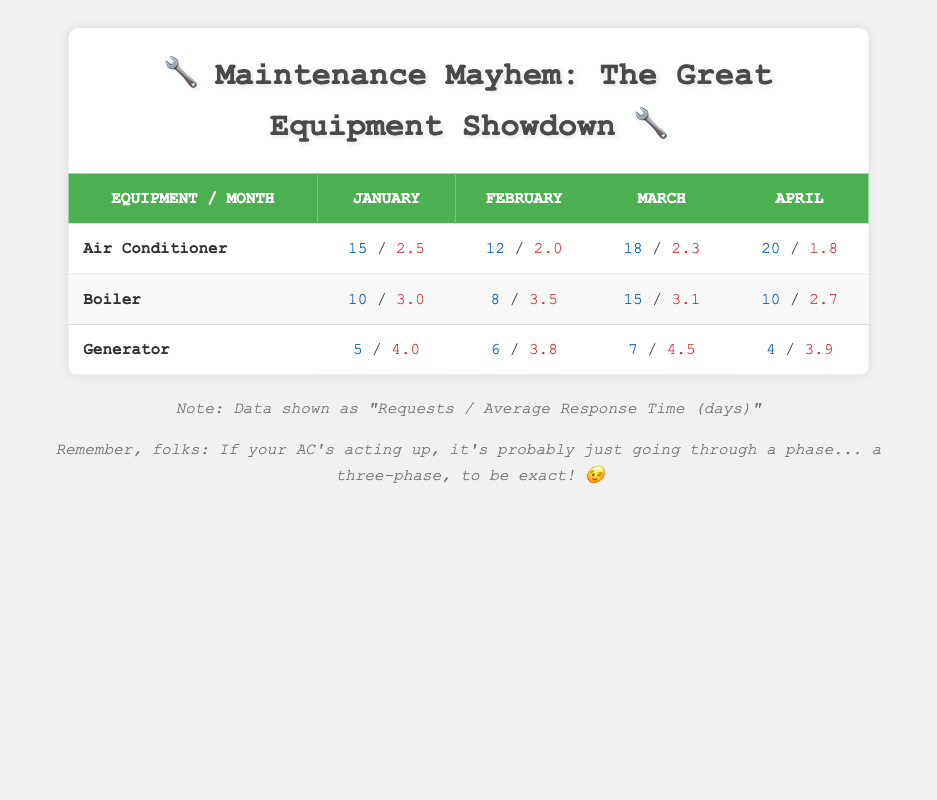What is the average response time for maintenance requests related to the Air Conditioner in April? In April, the average response time for the Air Conditioner is listed in the table as 1.8 days.
Answer: 1.8 days How many maintenance requests were made for the Generator in January? The table shows that there were 5 requests made for the Generator in January.
Answer: 5 requests Which equipment type had the highest number of maintenance requests in March? In March, the Air Conditioner had the highest requests with 18, compared to 15 for the Boiler and 7 for the Generator.
Answer: Air Conditioner What is the total number of maintenance requests for Boiler across all four months? The requests for Boiler in January (10), February (8), March (15), and April (10) total to 10 + 8 + 15 + 10 = 43 requests.
Answer: 43 requests Was the average response time for the Generator higher in January than in February? In January, the average response time for the Generator was 4.0 days, while in February, it was 3.8 days, thus it was higher in January.
Answer: Yes What is the difference in average response time between the Air Conditioner and the Boiler in March? The average response time for Air Conditioner in March is 2.3 days and for Boiler is 3.1 days. The difference is 3.1 - 2.3 = 0.8 days.
Answer: 0.8 days Which month had the lowest average response time for maintenance requests across all equipment types? April had the lowest average response time for Air Conditioner (1.8 days), Boiler (2.7 days), and Generator (3.9 days). Totaling the average gives us a lower value compared to other months.
Answer: April How many more requests were made for the Air Conditioner in April compared to the Generator in that same month? In April, there were 20 requests for Air Conditioner and 4 requests for Generator, resulting in a difference of 20 - 4 = 16 more requests.
Answer: 16 more requests Is it true that the average response time for the Boiler decreased from January to April? In January, the average response time for the Boiler was 3.0 days and in April it decreased to 2.7 days, thus confirming it was indeed true.
Answer: Yes 